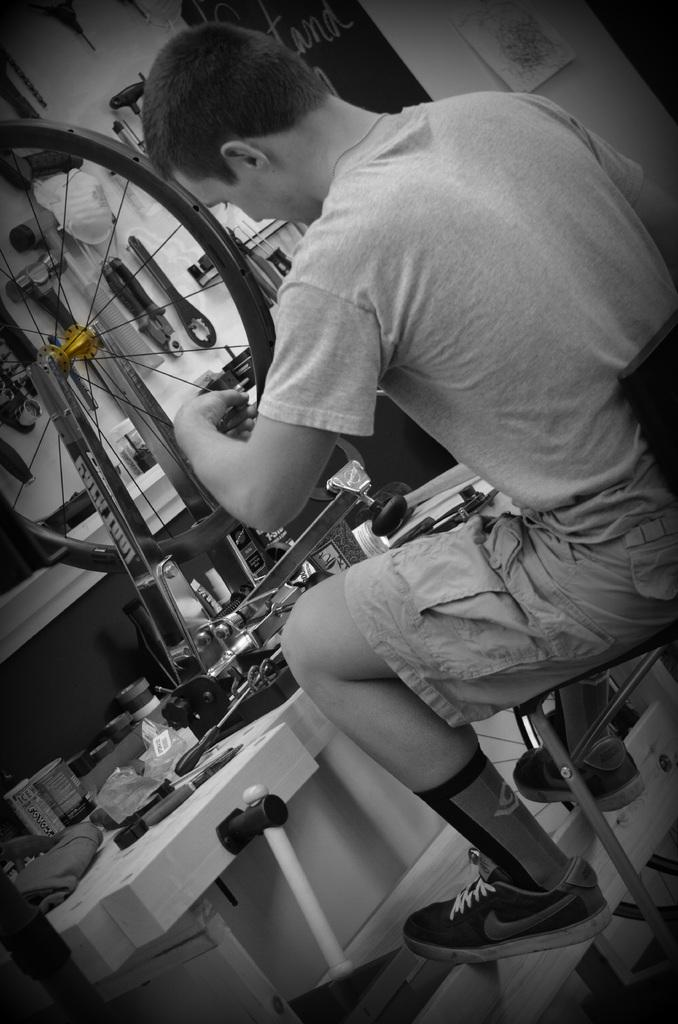What is the man in the image doing? The man is sitting on a chair in the image. What is the man holding in the image? The man is holding a wheel in the image. What can be seen on the surface in the image? There are objects on the surface in the image. What is visible on the wall in the background of the image? There are tools on a wall in the background of the image. How many legs does the thing on the wall have in the image? There is no "thing" with legs present in the image; the tools on the wall do not have legs. 